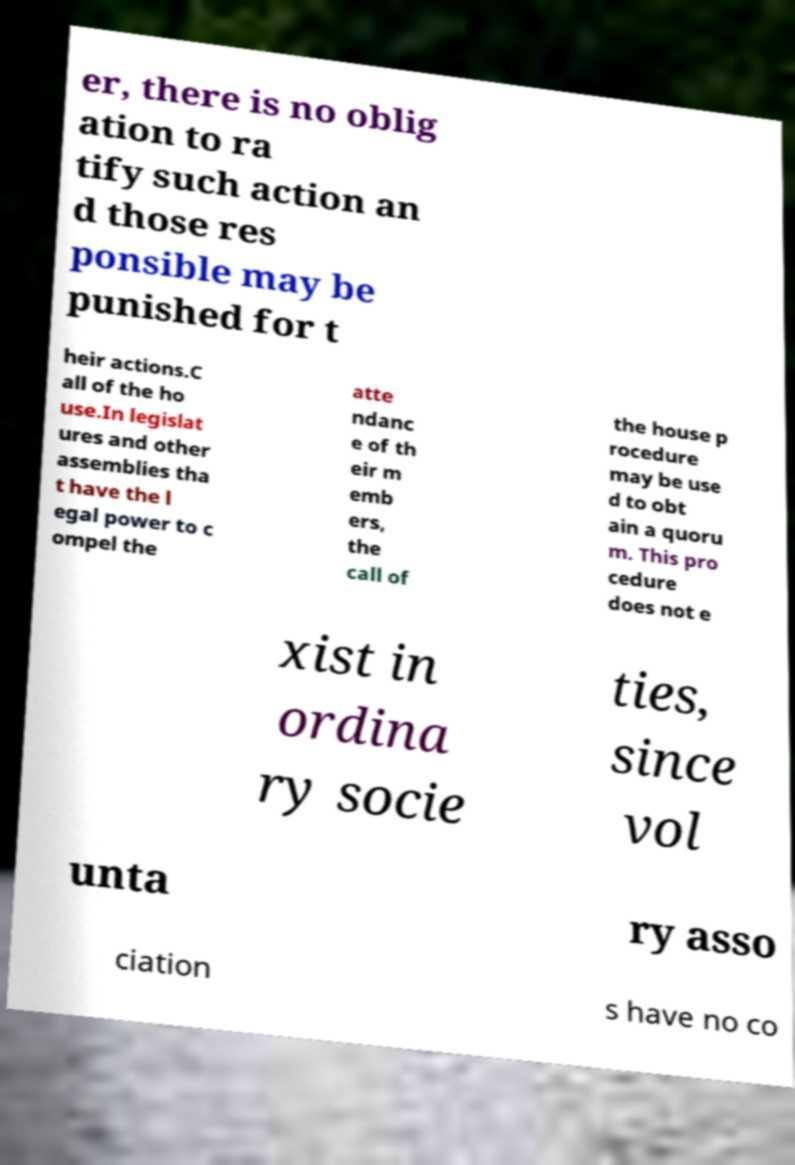Could you assist in decoding the text presented in this image and type it out clearly? er, there is no oblig ation to ra tify such action an d those res ponsible may be punished for t heir actions.C all of the ho use.In legislat ures and other assemblies tha t have the l egal power to c ompel the atte ndanc e of th eir m emb ers, the call of the house p rocedure may be use d to obt ain a quoru m. This pro cedure does not e xist in ordina ry socie ties, since vol unta ry asso ciation s have no co 